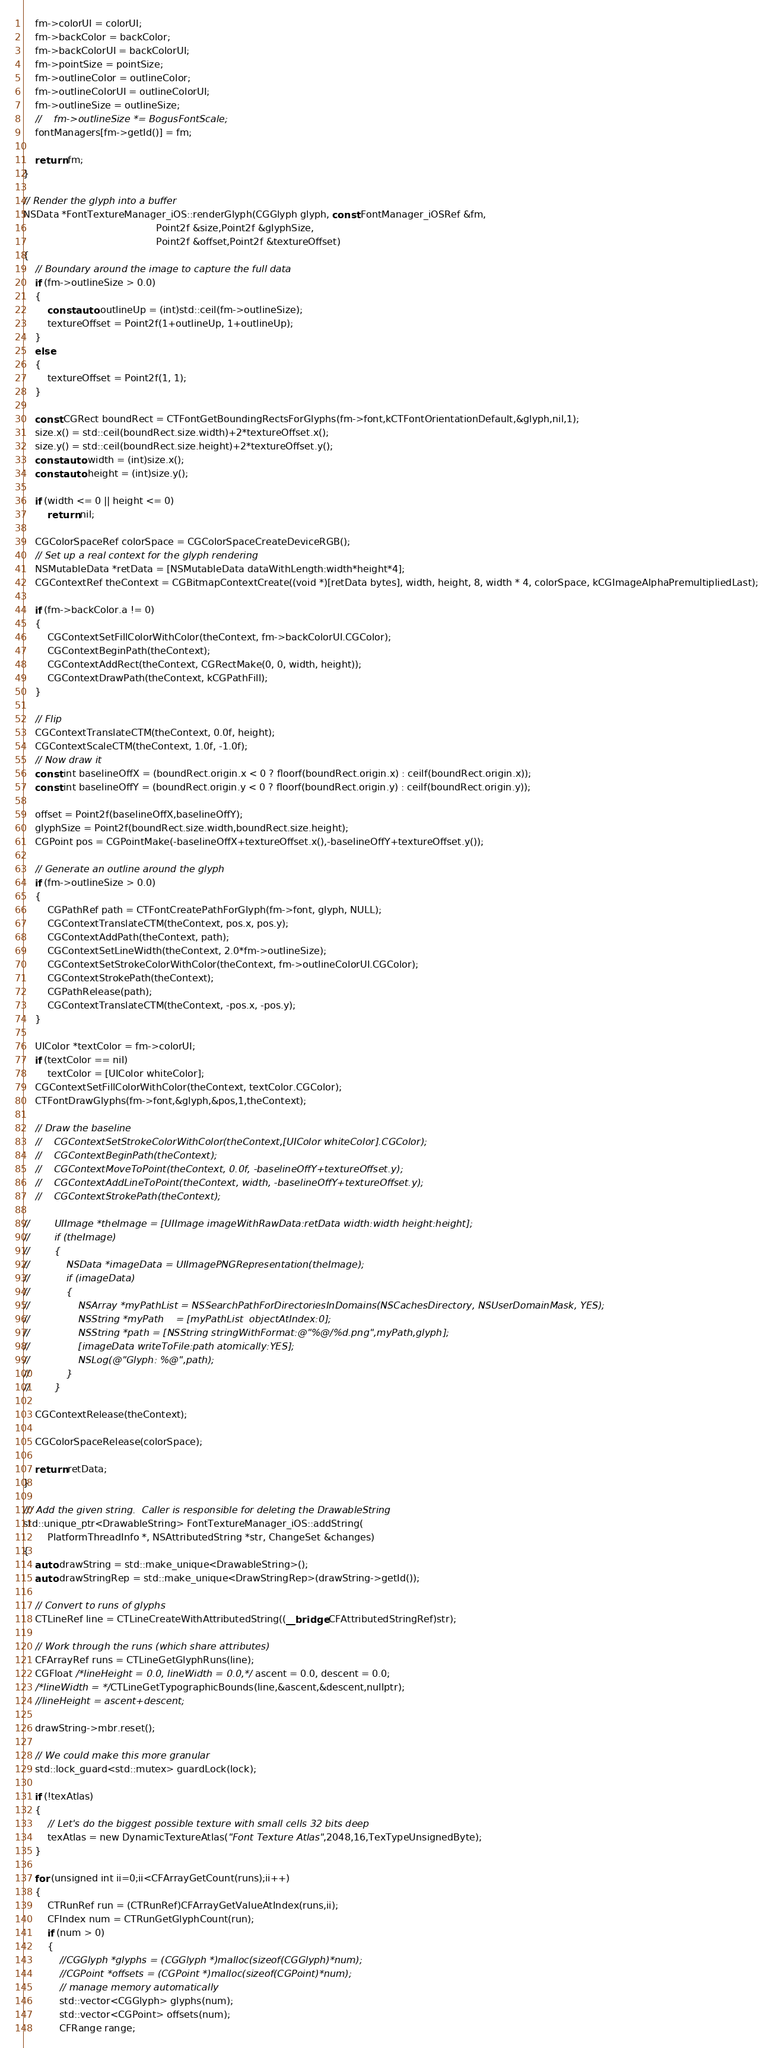<code> <loc_0><loc_0><loc_500><loc_500><_ObjectiveC_>    fm->colorUI = colorUI;
    fm->backColor = backColor;
    fm->backColorUI = backColorUI;
    fm->pointSize = pointSize;
    fm->outlineColor = outlineColor;
    fm->outlineColorUI = outlineColorUI;
    fm->outlineSize = outlineSize;
    //    fm->outlineSize *= BogusFontScale;
    fontManagers[fm->getId()] = fm;

    return fm;
}

// Render the glyph into a buffer
NSData *FontTextureManager_iOS::renderGlyph(CGGlyph glyph, const FontManager_iOSRef &fm,
                                            Point2f &size,Point2f &glyphSize,
                                            Point2f &offset,Point2f &textureOffset)
{
    // Boundary around the image to capture the full data
    if (fm->outlineSize > 0.0)
    {
        const auto outlineUp = (int)std::ceil(fm->outlineSize);
        textureOffset = Point2f(1+outlineUp, 1+outlineUp);
    }
    else
    {
        textureOffset = Point2f(1, 1);
    }
    
    const CGRect boundRect = CTFontGetBoundingRectsForGlyphs(fm->font,kCTFontOrientationDefault,&glyph,nil,1);
    size.x() = std::ceil(boundRect.size.width)+2*textureOffset.x();
    size.y() = std::ceil(boundRect.size.height)+2*textureOffset.y();
    const auto width = (int)size.x();
    const auto height = (int)size.y();

    if (width <= 0 || height <= 0)
        return nil;

    CGColorSpaceRef colorSpace = CGColorSpaceCreateDeviceRGB();
    // Set up a real context for the glyph rendering
    NSMutableData *retData = [NSMutableData dataWithLength:width*height*4];
    CGContextRef theContext = CGBitmapContextCreate((void *)[retData bytes], width, height, 8, width * 4, colorSpace, kCGImageAlphaPremultipliedLast);
    
    if (fm->backColor.a != 0)
    {
        CGContextSetFillColorWithColor(theContext, fm->backColorUI.CGColor);
        CGContextBeginPath(theContext);
        CGContextAddRect(theContext, CGRectMake(0, 0, width, height));
        CGContextDrawPath(theContext, kCGPathFill);
    }
    
    // Flip
    CGContextTranslateCTM(theContext, 0.0f, height);
    CGContextScaleCTM(theContext, 1.0f, -1.0f);
    // Now draw it
    const int baselineOffX = (boundRect.origin.x < 0 ? floorf(boundRect.origin.x) : ceilf(boundRect.origin.x));
    const int baselineOffY = (boundRect.origin.y < 0 ? floorf(boundRect.origin.y) : ceilf(boundRect.origin.y));
    
    offset = Point2f(baselineOffX,baselineOffY);
    glyphSize = Point2f(boundRect.size.width,boundRect.size.height);
    CGPoint pos = CGPointMake(-baselineOffX+textureOffset.x(),-baselineOffY+textureOffset.y());
    
    // Generate an outline around the glyph
    if (fm->outlineSize > 0.0)
    {
        CGPathRef path = CTFontCreatePathForGlyph(fm->font, glyph, NULL);
        CGContextTranslateCTM(theContext, pos.x, pos.y);
        CGContextAddPath(theContext, path);
        CGContextSetLineWidth(theContext, 2.0*fm->outlineSize);
        CGContextSetStrokeColorWithColor(theContext, fm->outlineColorUI.CGColor);
        CGContextStrokePath(theContext);
        CGPathRelease(path);
        CGContextTranslateCTM(theContext, -pos.x, -pos.y);
    }
    
    UIColor *textColor = fm->colorUI;
    if (textColor == nil)
        textColor = [UIColor whiteColor];
    CGContextSetFillColorWithColor(theContext, textColor.CGColor);
    CTFontDrawGlyphs(fm->font,&glyph,&pos,1,theContext);

    // Draw the baseline
    //    CGContextSetStrokeColorWithColor(theContext,[UIColor whiteColor].CGColor);
    //    CGContextBeginPath(theContext);
    //    CGContextMoveToPoint(theContext, 0.0f, -baselineOffY+textureOffset.y);
    //    CGContextAddLineToPoint(theContext, width, -baselineOffY+textureOffset.y);
    //    CGContextStrokePath(theContext);

//        UIImage *theImage = [UIImage imageWithRawData:retData width:width height:height];
//        if (theImage)
//        {
//            NSData *imageData = UIImagePNGRepresentation(theImage);
//            if (imageData)
//            {
//                NSArray *myPathList = NSSearchPathForDirectoriesInDomains(NSCachesDirectory, NSUserDomainMask, YES);
//                NSString *myPath    = [myPathList  objectAtIndex:0];
//                NSString *path = [NSString stringWithFormat:@"%@/%d.png",myPath,glyph];
//                [imageData writeToFile:path atomically:YES];
//                NSLog(@"Glyph: %@",path);
//            }
//        }

    CGContextRelease(theContext);

    CGColorSpaceRelease(colorSpace);

    return retData;
}

/// Add the given string.  Caller is responsible for deleting the DrawableString
std::unique_ptr<DrawableString> FontTextureManager_iOS::addString(
        PlatformThreadInfo *, NSAttributedString *str, ChangeSet &changes)
{
    auto drawString = std::make_unique<DrawableString>();
    auto drawStringRep = std::make_unique<DrawStringRep>(drawString->getId());

    // Convert to runs of glyphs
    CTLineRef line = CTLineCreateWithAttributedString((__bridge CFAttributedStringRef)str);

    // Work through the runs (which share attributes)
    CFArrayRef runs = CTLineGetGlyphRuns(line);
    CGFloat /*lineHeight = 0.0, lineWidth = 0.0,*/ ascent = 0.0, descent = 0.0;
    /*lineWidth = */CTLineGetTypographicBounds(line,&ascent,&descent,nullptr);
    //lineHeight = ascent+descent;

    drawString->mbr.reset();

    // We could make this more granular
    std::lock_guard<std::mutex> guardLock(lock);
    
    if (!texAtlas)
    {
        // Let's do the biggest possible texture with small cells 32 bits deep
        texAtlas = new DynamicTextureAtlas("Font Texture Atlas",2048,16,TexTypeUnsignedByte);
    }

    for (unsigned int ii=0;ii<CFArrayGetCount(runs);ii++)
    {
        CTRunRef run = (CTRunRef)CFArrayGetValueAtIndex(runs,ii);
        CFIndex num = CTRunGetGlyphCount(run);
        if (num > 0)
        {
            //CGGlyph *glyphs = (CGGlyph *)malloc(sizeof(CGGlyph)*num);
            //CGPoint *offsets = (CGPoint *)malloc(sizeof(CGPoint)*num);
            // manage memory automatically
            std::vector<CGGlyph> glyphs(num);
            std::vector<CGPoint> offsets(num);
            CFRange range;</code> 